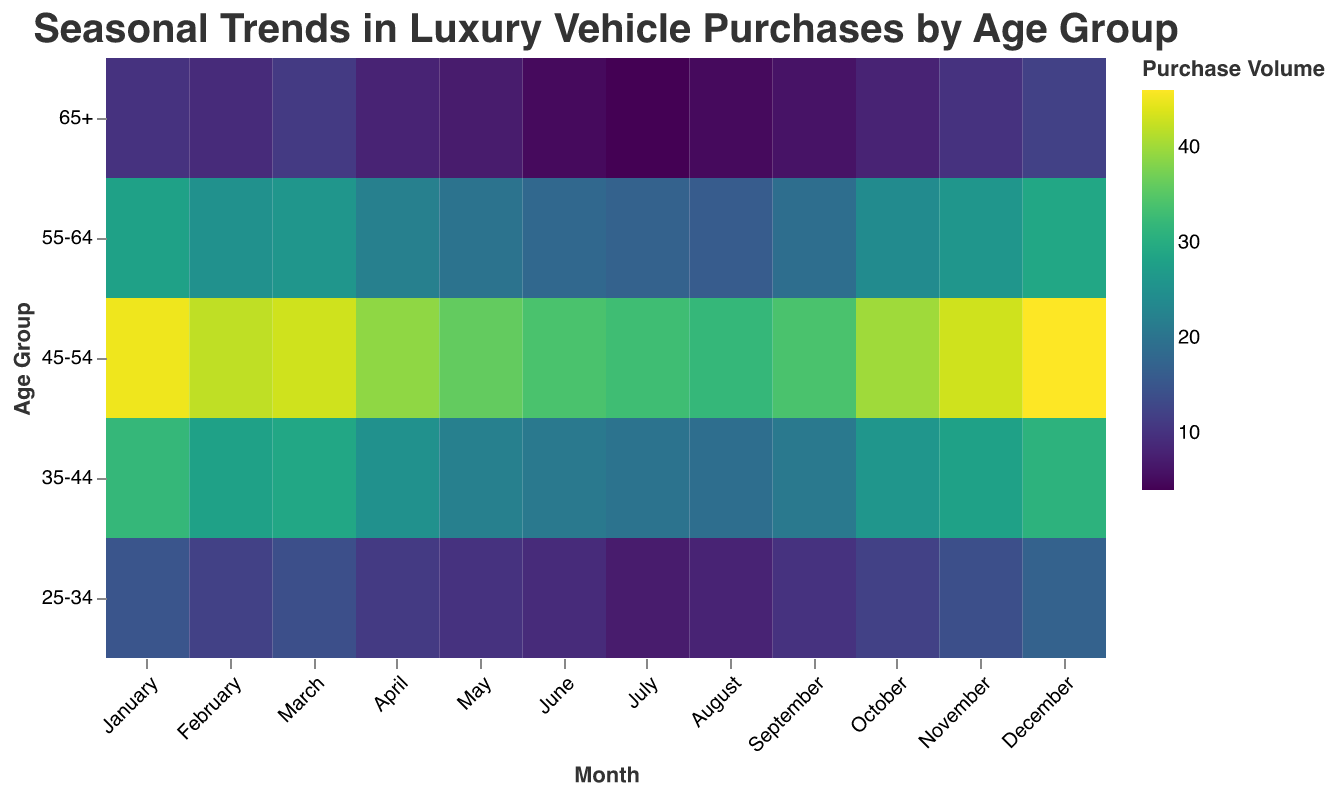Which age group had the highest purchase volume in January? To answer this, look at the color intensities for January on the heatmap and identify the brightest cell in that column. The age group 45-54 has the highest value.
Answer: 45-54 In which month did the 25-34 age group purchase the most vehicles? Check the row corresponding to the 25-34 age group and find the month with the brightest color. December shows the highest value of 17.
Answer: December Which month shows the lowest purchase volume for the 65+ age group? Examine the row for the 65+ age group and find the month with the darkest color. July has the lowest value at 4.
Answer: July What is the combined purchase volume for the 35-44 age group in the first quarter (January, February, March)? Add the purchase volumes for January (32), February (28), and March (29) for the 35-44 age group. The sum is 32 + 28 + 29 = 89.
Answer: 89 By how much did the purchase volume for the 55-64 age group increase from July to October? Subtract the purchase value in July (17) from the value in October (24). The increase is 24 - 17 = 7.
Answer: 7 Which age group had the most significant purchase volume fluctuation throughout the year? Compare the range of values for each age group by finding the difference between the maximum and the minimum purchase volumes. The 45-54 age group has the highest fluctuation with values ranging from 33 to 46.
Answer: 45-54 Identify the month with the overall highest purchase volume across all age groups. Sum the values for each month and identify the highest sum total. December has the highest total with (17 + 31 + 46 + 29 + 12) = 135.
Answer: December How many age groups have their peak purchase period in December? Check each age group and see if their highest purchase volume falls in December. The age groups 25-34, 35-44, 45-54, 55-64, and 65+ all have their peaks in December.
Answer: 5 Did the 35-44 age group purchase more vehicles in August or November? Compare the values for the 35-44 age group in August (19) and November (28). November has a higher value.
Answer: November Is there any age group that consistently shows a lower purchase volume during the summer months (June, July, August)? Check the values for June, July, and August for each age group. The 65+ age group consistently shows lower values (5, 4, and 5).
Answer: 65+ 